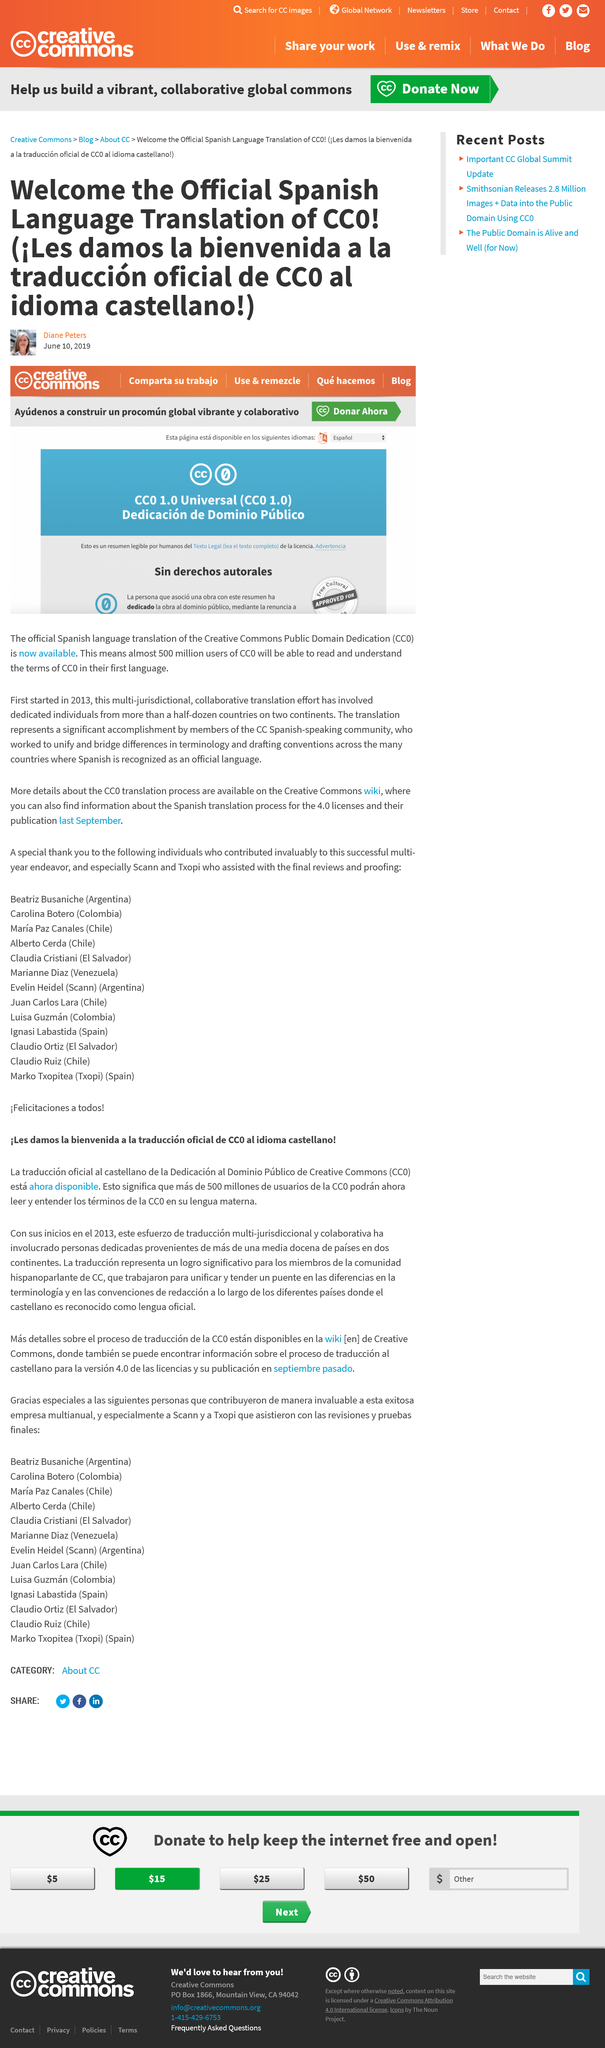Indicate a few pertinent items in this graphic. Almost 500 million users of CC0 will be able to read and understand the terms of CC0 in their first language. The author of the text is Diane Peters. The date of publication is June 10, 2019. 